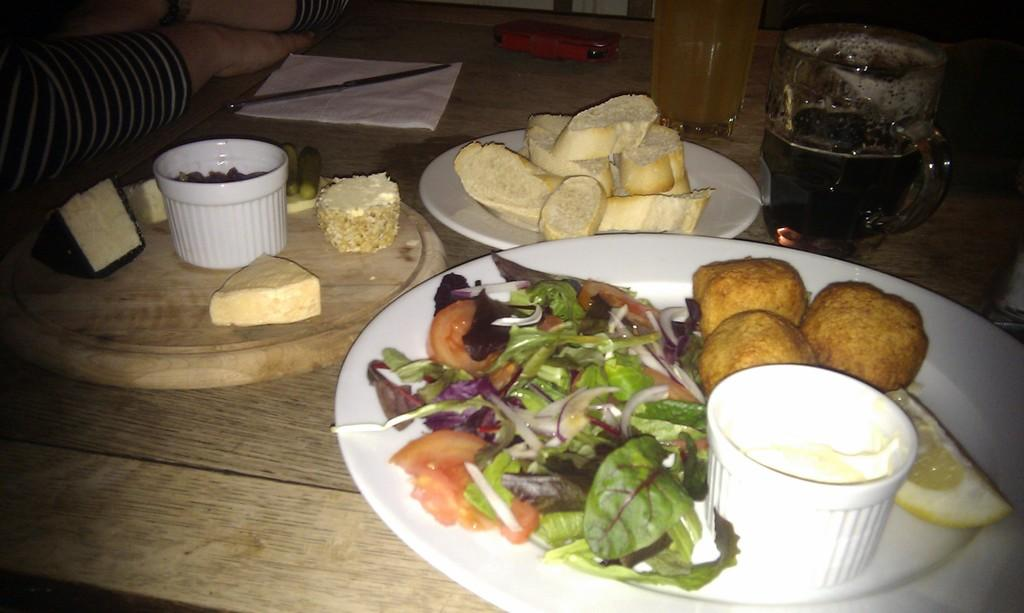What is the main object in the center of the image? There is a table in the center of the image. What items can be seen on the table? There are plates, bowls, glasses, a mobile, napkins, knives, a board, and butter on the table. Can you describe the person in the image? There is a person on the left side of the image. What type of guitar is the person playing in the image? There is no guitar present in the image; the person is not playing any instrument. What season is depicted in the image? The image does not depict a specific season, as there are no seasonal cues present. 